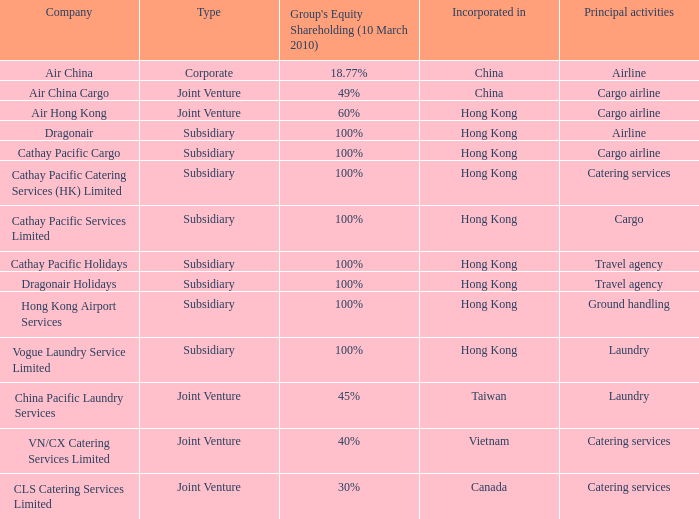Which company has a group equity shareholding percentage, as of March 10th 2010 of 30%? CLS Catering Services Limited. 